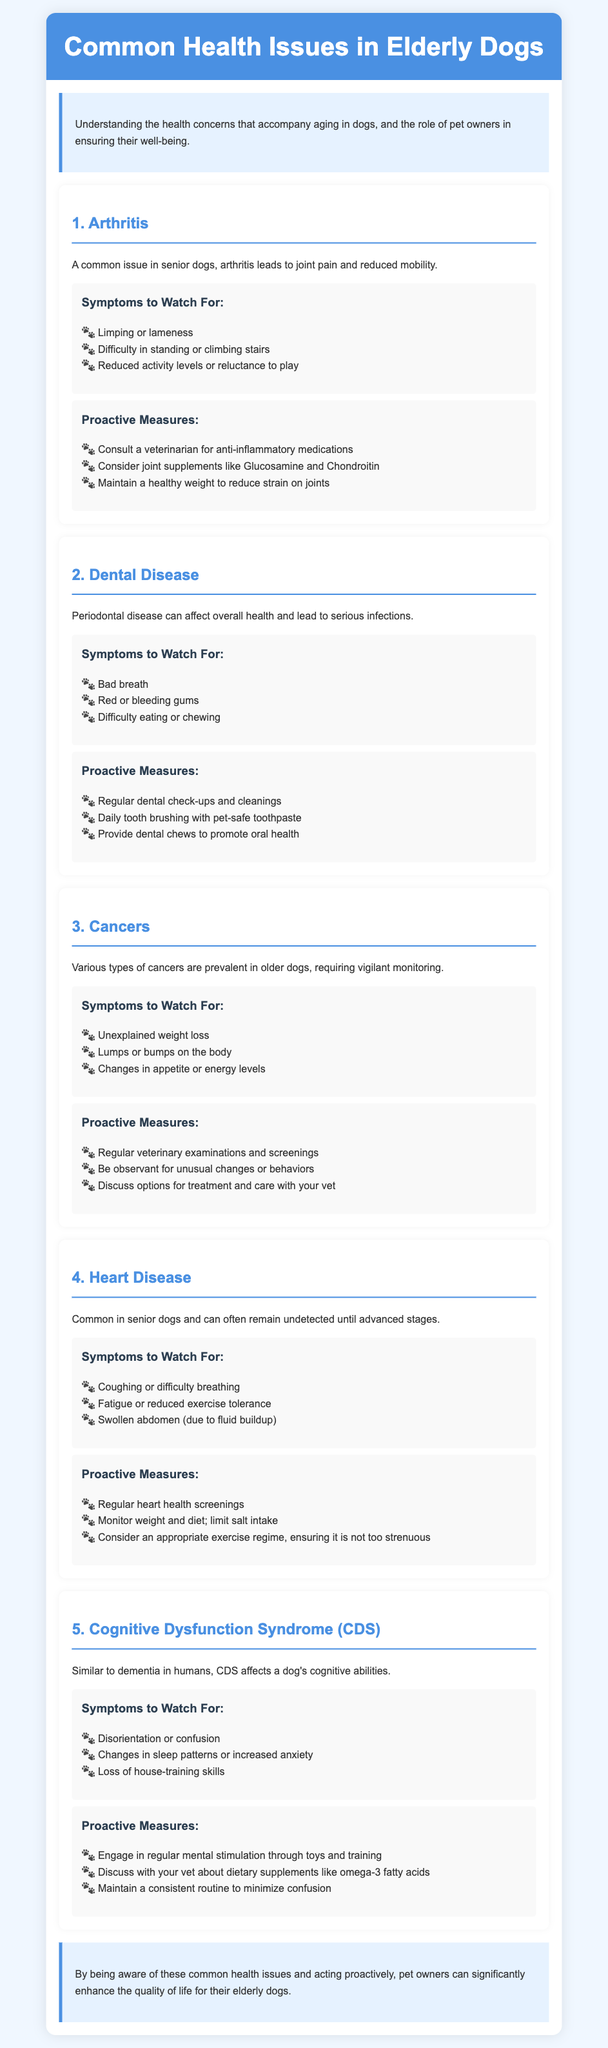What is a common issue in senior dogs? The document states that arthritis is a common issue in senior dogs.
Answer: Arthritis What symptoms indicate arthritis in elderly dogs? The symptoms include limping or lameness, difficulty in standing or climbing stairs, and reduced activity levels or reluctance to play.
Answer: Limping or lameness, difficulty in standing or climbing stairs, reduced activity levels What health issue can lead to serious infections in dogs? The document mentions dental disease as a health issue that can lead to serious infections.
Answer: Dental Disease Name one proactive measure for heart disease in elderly dogs. The document lists several proactive measures, such as regular heart health screenings and monitoring weight and diet.
Answer: Regular heart health screenings What are the symptoms of Cognitive Dysfunction Syndrome (CDS)? Symptoms of CDS include disorientation or confusion, changes in sleep patterns or increased anxiety, and loss of house-training skills.
Answer: Disorientation or confusion, changes in sleep patterns, loss of house-training skills Which type of cancer symptoms require vigilant monitoring? The document states that various types of cancers are prevalent in older dogs, requiring vigilant monitoring.
Answer: Various types of cancers How can pet owners significantly enhance their elderly dogs' quality of life? The conclusion emphasizes being aware of common health issues and acting proactively as ways to enhance quality of life for elderly dogs.
Answer: Being aware of common health issues and acting proactively What dietary supplement does the document suggest discussing with a vet for CDS? It mentions discussing dietary supplements like omega-3 fatty acids with the veterinarian.
Answer: Omega-3 fatty acids 